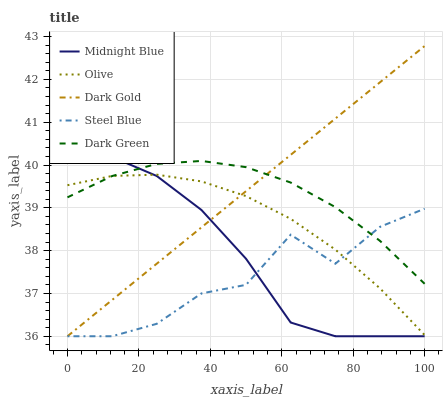Does Steel Blue have the minimum area under the curve?
Answer yes or no. Yes. Does Dark Gold have the maximum area under the curve?
Answer yes or no. Yes. Does Dark Green have the minimum area under the curve?
Answer yes or no. No. Does Dark Green have the maximum area under the curve?
Answer yes or no. No. Is Dark Gold the smoothest?
Answer yes or no. Yes. Is Steel Blue the roughest?
Answer yes or no. Yes. Is Dark Green the smoothest?
Answer yes or no. No. Is Dark Green the roughest?
Answer yes or no. No. Does Dark Green have the lowest value?
Answer yes or no. No. Does Dark Gold have the highest value?
Answer yes or no. Yes. Does Dark Green have the highest value?
Answer yes or no. No. Does Steel Blue intersect Dark Green?
Answer yes or no. Yes. Is Steel Blue less than Dark Green?
Answer yes or no. No. Is Steel Blue greater than Dark Green?
Answer yes or no. No. 